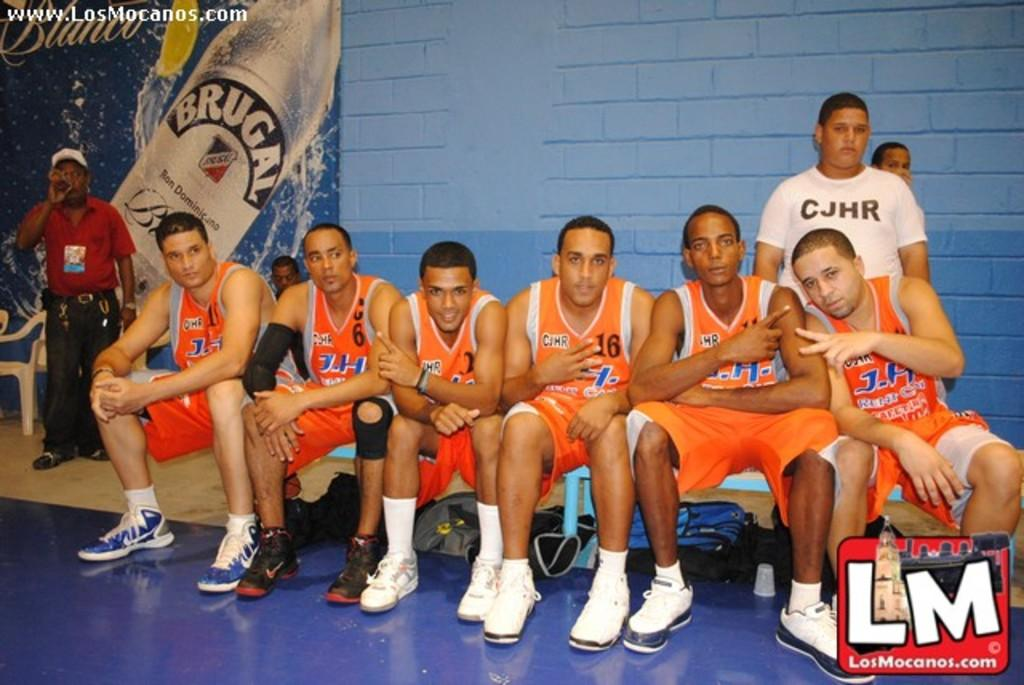<image>
Describe the image concisely. A basket ball team wearing orange strips pose for a photo in front of an advert for Brugal lager 